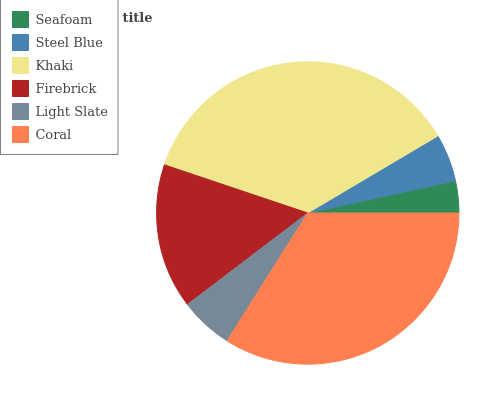Is Seafoam the minimum?
Answer yes or no. Yes. Is Khaki the maximum?
Answer yes or no. Yes. Is Steel Blue the minimum?
Answer yes or no. No. Is Steel Blue the maximum?
Answer yes or no. No. Is Steel Blue greater than Seafoam?
Answer yes or no. Yes. Is Seafoam less than Steel Blue?
Answer yes or no. Yes. Is Seafoam greater than Steel Blue?
Answer yes or no. No. Is Steel Blue less than Seafoam?
Answer yes or no. No. Is Firebrick the high median?
Answer yes or no. Yes. Is Light Slate the low median?
Answer yes or no. Yes. Is Seafoam the high median?
Answer yes or no. No. Is Coral the low median?
Answer yes or no. No. 